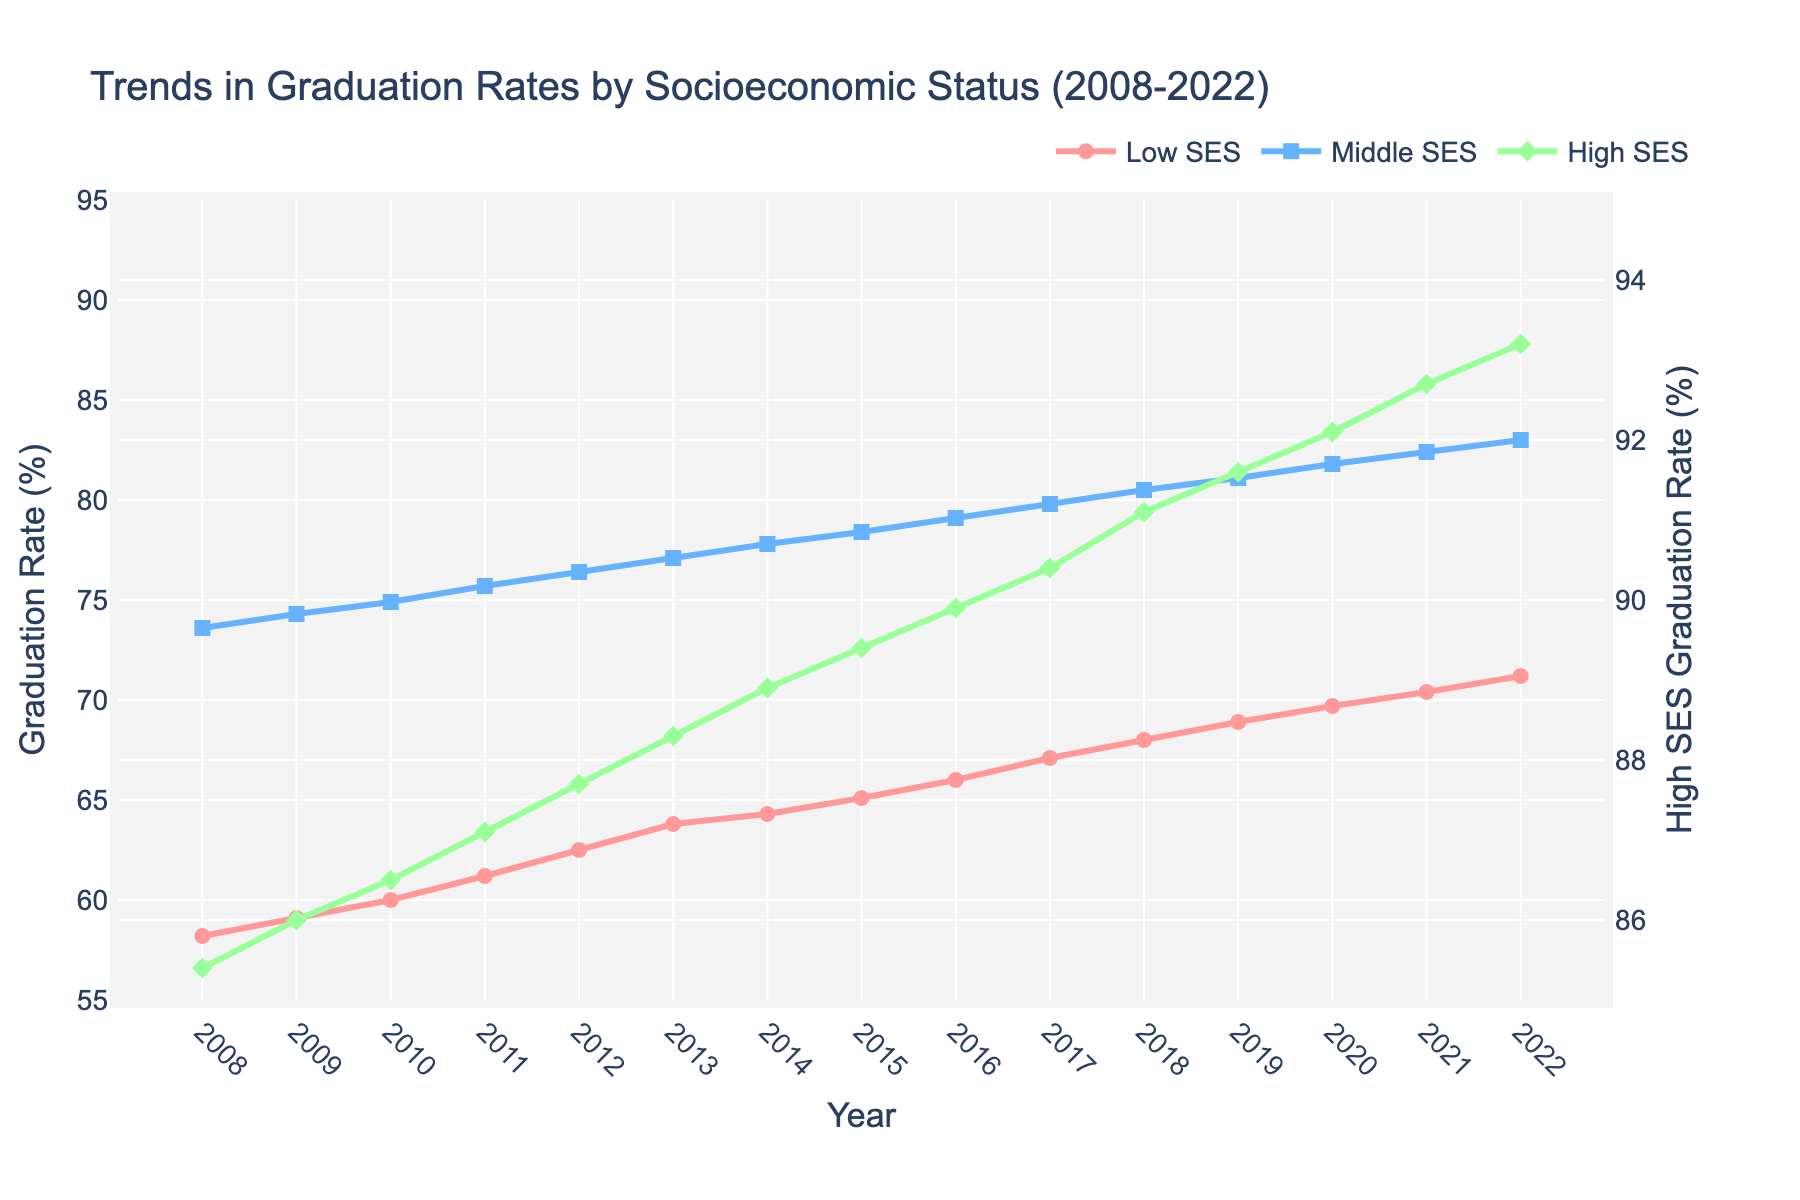What is the year range shown in the figure? The x-axis displays years, and the data points start from 2008 and end at 2022.
Answer: 2008-2022 Which group has the highest graduation rate in 2022? By looking at the data points for 2022: High SES is at 93.2%, Middle SES is at 83.0%, and Low SES is at 71.2%. The highest graduation rate belongs to High SES.
Answer: High SES What is the difference in graduation rates between High SES and Low SES in 2010? From the data points in 2010: High SES rate is 86.5%, and Low SES rate is 60.0%. The difference is calculated as 86.5% - 60.0%.
Answer: 26.5% How much did the graduation rate for Low SES change from 2008 to 2022? In 2008, Low SES had a graduation rate of 58.2%, and in 2022, it is 71.2%. The change is calculated as 71.2% - 58.2%.
Answer: 13% Which group showed the most significant increase in graduation rates over the 15 years? By comparing the changes for each group from 2008 to 2022: Low SES changed by 13%, Middle SES by 9.4% (83.0% - 73.6%), and High SES by 7.8% (93.2% - 85.4%). The Low SES group had the most significant increase.
Answer: Low SES Did any of the SES groups experience a drop in graduation rates at any point during the 15 years? Examining all three lines on the plot, none of the groups show a decrease year-on-year; they all show a continuous upward trend in graduation rates.
Answer: No Which years show the graduation rate for Middle SES crossing 80%? Observing the Middle SES data points and markers, it crosses 80% in the year 2017.
Answer: 2017 By how many percentage points did the graduation rate for Middle SES increase from 2014 to 2019? Middle SES rate in 2014 is 77.8%, and in 2019 it is 81.1%. The increase is calculated as 81.1% - 77.8%.
Answer: 3.3% What is the title of the figure? The title is prominently displayed at the top center of the figure and reads: "Trends in Graduation Rates by Socioeconomic Status (2008-2022)".
Answer: Trends in Graduation Rates by Socioeconomic Status (2008-2022) Which SES group consistently had graduation rates above 85% throughout the 15 years? High SES consistently had graduation rates above 85%, as seen in the data points ranging from 85.4% in 2008 to 93.2% in 2022.
Answer: High SES 